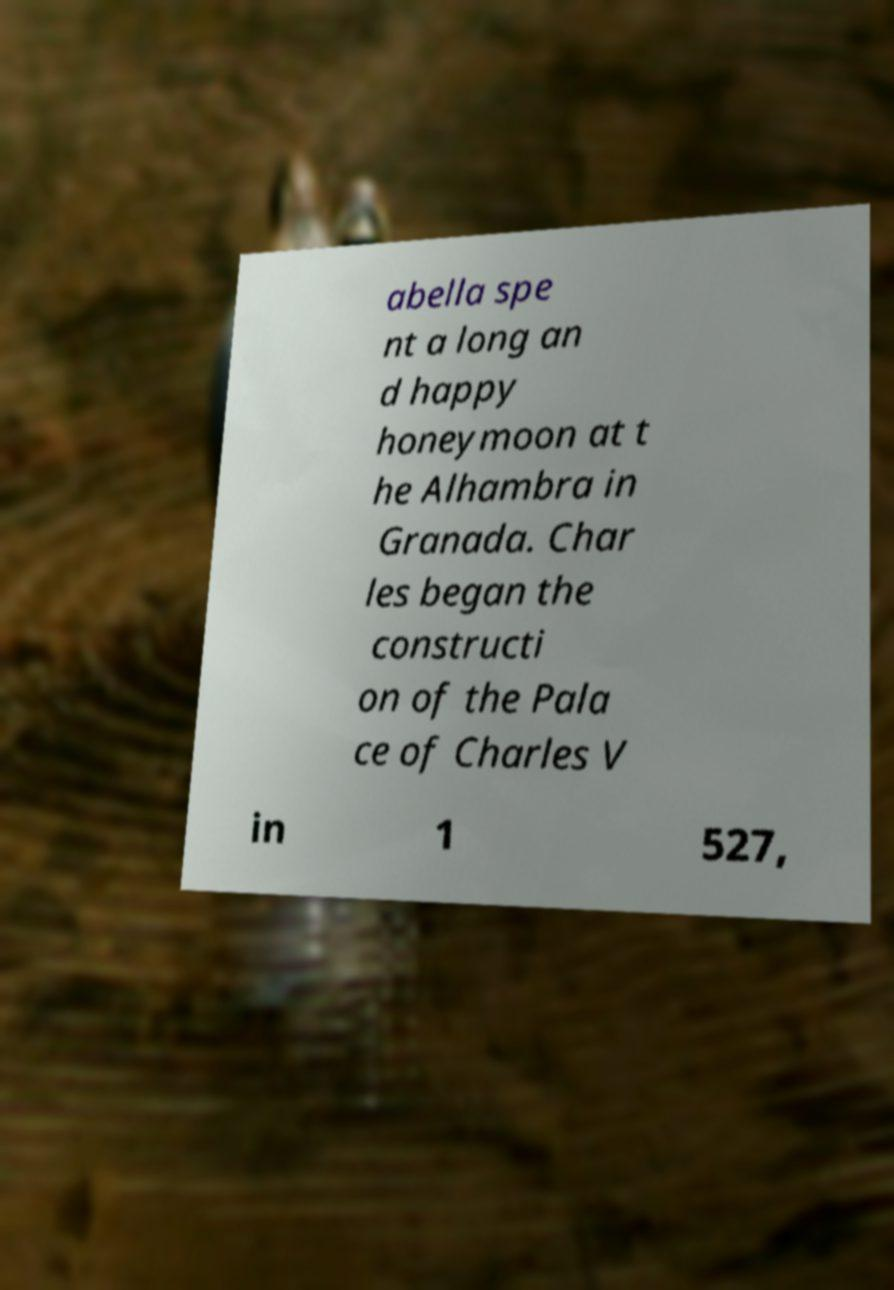Please identify and transcribe the text found in this image. abella spe nt a long an d happy honeymoon at t he Alhambra in Granada. Char les began the constructi on of the Pala ce of Charles V in 1 527, 